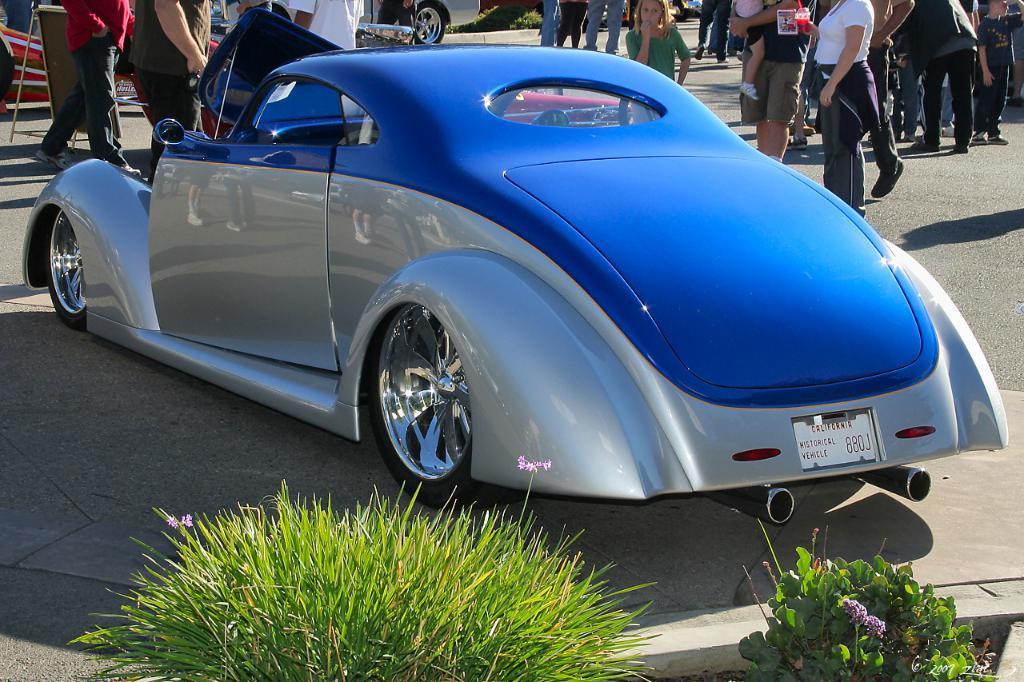Please provide a concise description of this image. In this image, I can see a car and groups of people standing on the road. At the top corner of the image, I can see a vehicle. At the bottom of the image, there are plants. 